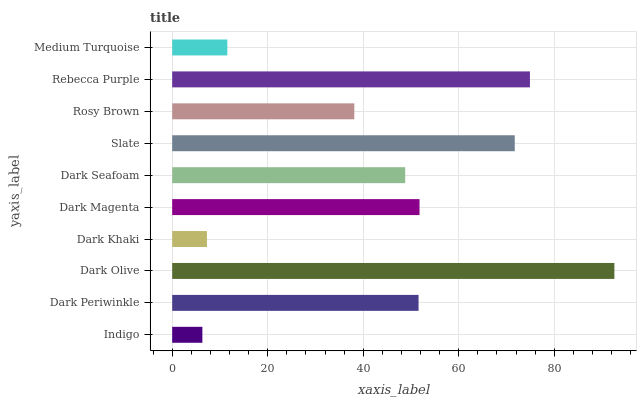Is Indigo the minimum?
Answer yes or no. Yes. Is Dark Olive the maximum?
Answer yes or no. Yes. Is Dark Periwinkle the minimum?
Answer yes or no. No. Is Dark Periwinkle the maximum?
Answer yes or no. No. Is Dark Periwinkle greater than Indigo?
Answer yes or no. Yes. Is Indigo less than Dark Periwinkle?
Answer yes or no. Yes. Is Indigo greater than Dark Periwinkle?
Answer yes or no. No. Is Dark Periwinkle less than Indigo?
Answer yes or no. No. Is Dark Periwinkle the high median?
Answer yes or no. Yes. Is Dark Seafoam the low median?
Answer yes or no. Yes. Is Rosy Brown the high median?
Answer yes or no. No. Is Dark Khaki the low median?
Answer yes or no. No. 